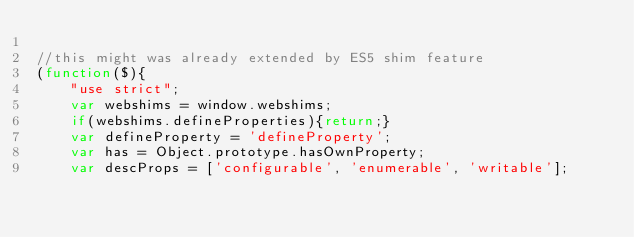Convert code to text. <code><loc_0><loc_0><loc_500><loc_500><_JavaScript_>
//this might was already extended by ES5 shim feature
(function($){
	"use strict";
	var webshims = window.webshims;
	if(webshims.defineProperties){return;}
	var defineProperty = 'defineProperty';
	var has = Object.prototype.hasOwnProperty;
	var descProps = ['configurable', 'enumerable', 'writable'];</code> 